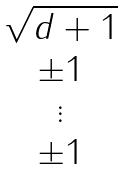Convert formula to latex. <formula><loc_0><loc_0><loc_500><loc_500>\begin{matrix} \sqrt { d + 1 } \\ \pm 1 \\ \vdots \\ \pm 1 \end{matrix}</formula> 